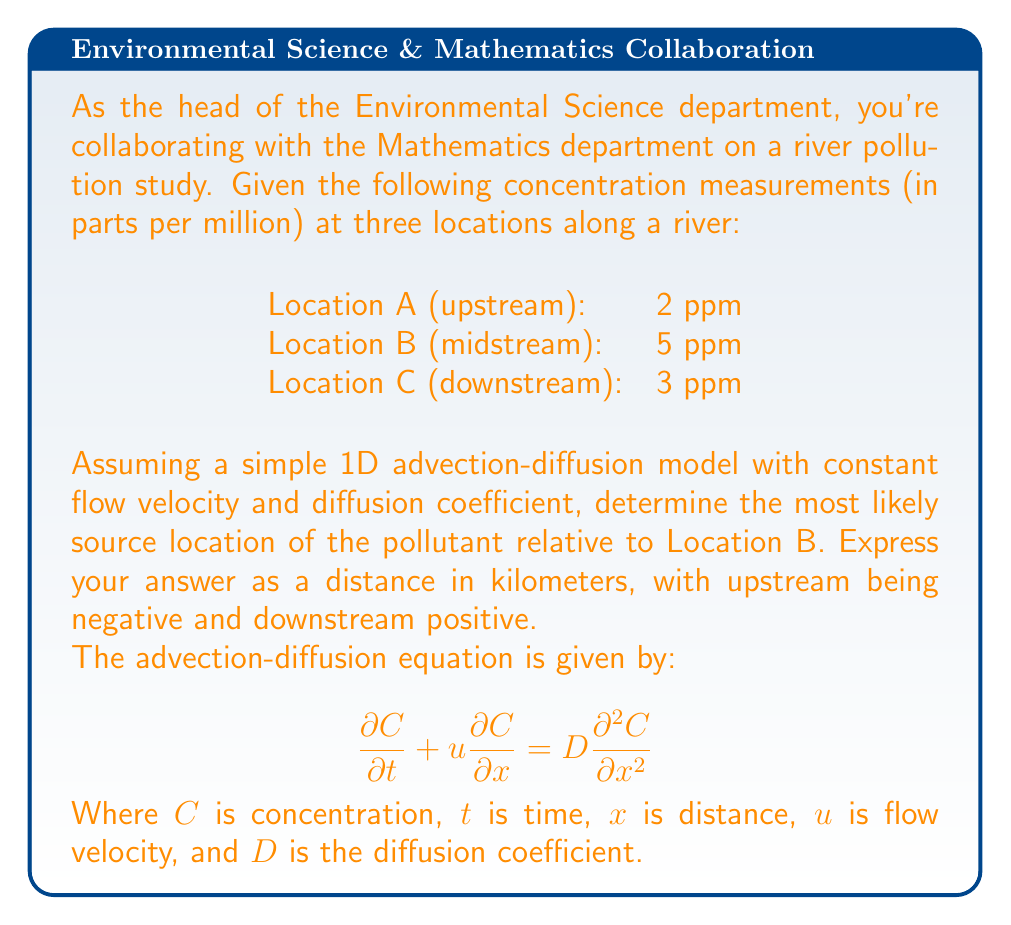What is the answer to this math problem? To solve this inverse problem, we'll use the steady-state solution of the advection-diffusion equation and the given concentration measurements. The steps are as follows:

1) The steady-state solution to the advection-diffusion equation is:

   $$C(x) = C_0 e^{\frac{u(x-x_0)}{D}}$$

   Where $C_0$ is the concentration at the source, $x_0$ is the source location, and $x$ is the measurement location.

2) Taking the logarithm of both sides:

   $$\ln(C(x)) = \ln(C_0) + \frac{u(x-x_0)}{D}$$

3) This is a linear equation in $x$. The slope of this line is $\frac{u}{D}$, and the x-intercept gives us the source location $x_0$.

4) Using the given measurements, we can plot $\ln(C)$ vs $x$:

   Location A: $\ln(2)$ at $x=-L$
   Location B: $\ln(5)$ at $x=0$
   Location C: $\ln(3)$ at $x=L$

   Where $L$ is the distance between measurement points.

5) To find the x-intercept (source location), we can use the slope between points B and C:

   $$\text{slope} = \frac{\ln(3) - \ln(5)}{L} = -\frac{0.51}{L}$$

6) The equation of the line passing through point B is:

   $$y = -\frac{0.51}{L}x + \ln(5)$$

7) Setting $y=0$ and solving for $x$ gives us the source location relative to point B:

   $$0 = -\frac{0.51}{L}x + \ln(5)$$
   $$x = \frac{L\ln(5)}{0.51} \approx 3.13L$$

8) Therefore, the source is approximately $3.13L$ downstream from Location B.
Answer: $3.13L$ km downstream from Location B 